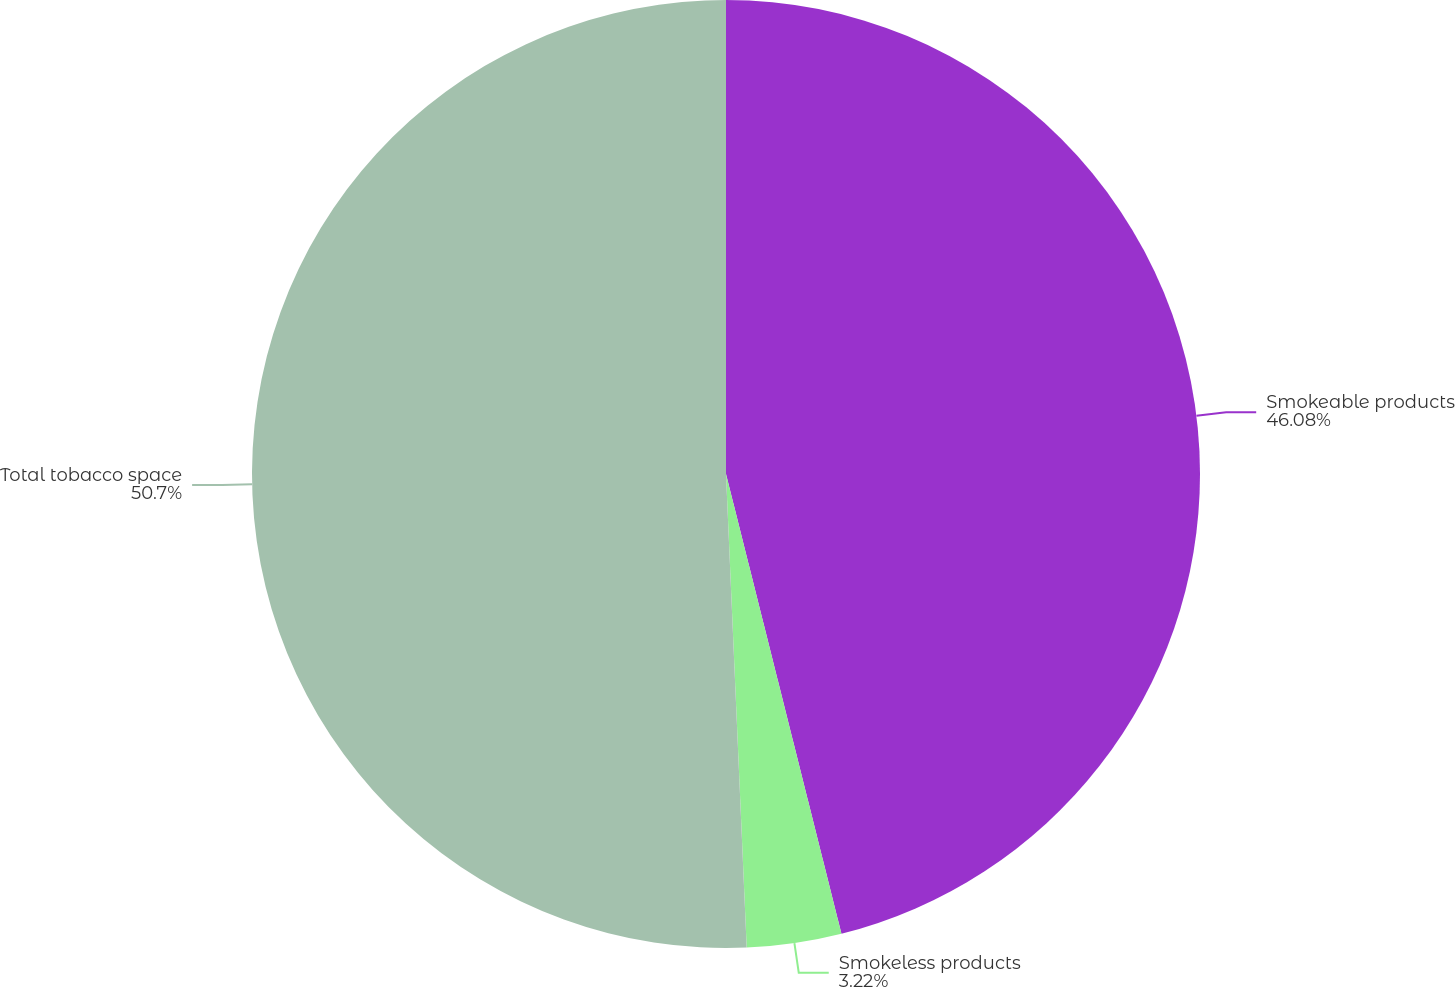<chart> <loc_0><loc_0><loc_500><loc_500><pie_chart><fcel>Smokeable products<fcel>Smokeless products<fcel>Total tobacco space<nl><fcel>46.08%<fcel>3.22%<fcel>50.69%<nl></chart> 